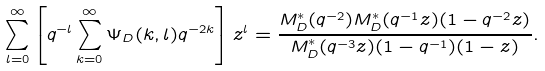Convert formula to latex. <formula><loc_0><loc_0><loc_500><loc_500>\sum _ { l = 0 } ^ { \infty } \left [ q ^ { - l } \sum _ { k = 0 } ^ { \infty } \Psi _ { D } ( k , l ) q ^ { - 2 k } \right ] z ^ { l } = \frac { M ^ { * } _ { D } ( q ^ { - 2 } ) M ^ { * } _ { D } ( q ^ { - 1 } z ) ( 1 - q ^ { - 2 } z ) } { M ^ { * } _ { D } ( q ^ { - 3 } z ) ( 1 - q ^ { - 1 } ) ( 1 - z ) } .</formula> 